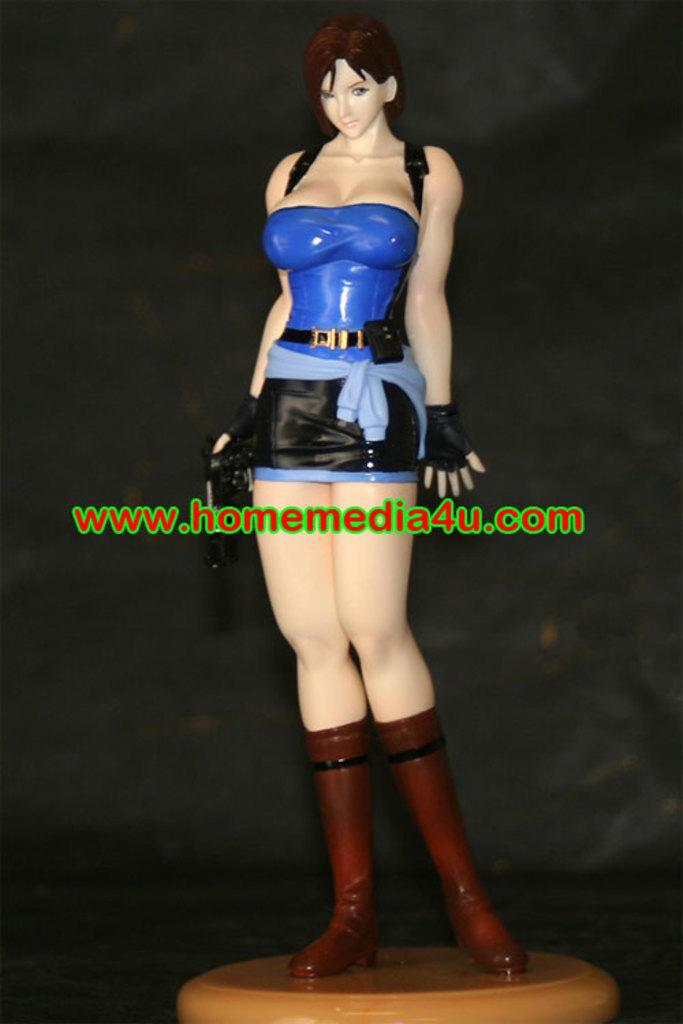What is the main subject of the picture? The main subject of the picture is an animation of a woman. Where is the animation located in the picture? The animation is in the middle of the picture. What else is present in the middle of the picture besides the animation? There is text in the middle of the picture. What is the color of the background in the image? The background of the image is dark. What type of celery is being used as a stem for the woman's hair in the image? There is no celery or any hair accessories present in the image; it features an animation of a woman with no visible hair accessories. 